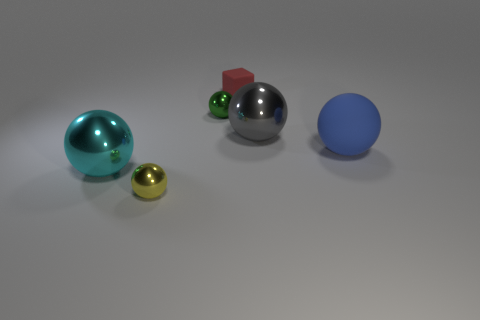Subtract all yellow spheres. How many spheres are left? 4 Subtract all green balls. How many balls are left? 4 Subtract all purple balls. Subtract all green cubes. How many balls are left? 5 Add 4 green metallic things. How many objects exist? 10 Subtract all spheres. How many objects are left? 1 Subtract all purple shiny cubes. Subtract all tiny red rubber blocks. How many objects are left? 5 Add 1 red blocks. How many red blocks are left? 2 Add 1 cyan balls. How many cyan balls exist? 2 Subtract 0 yellow cylinders. How many objects are left? 6 